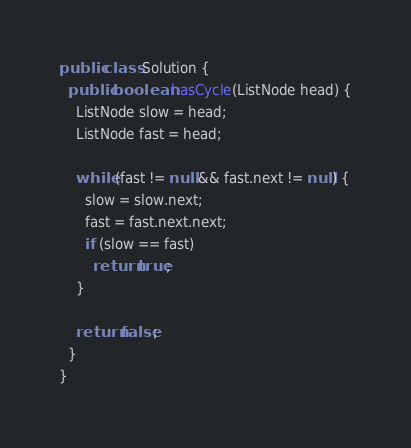Convert code to text. <code><loc_0><loc_0><loc_500><loc_500><_Java_>public class Solution {
  public boolean hasCycle(ListNode head) {
    ListNode slow = head;
    ListNode fast = head;

    while (fast != null && fast.next != null) {
      slow = slow.next;
      fast = fast.next.next;
      if (slow == fast)
        return true;
    }

    return false;
  }
}
</code> 